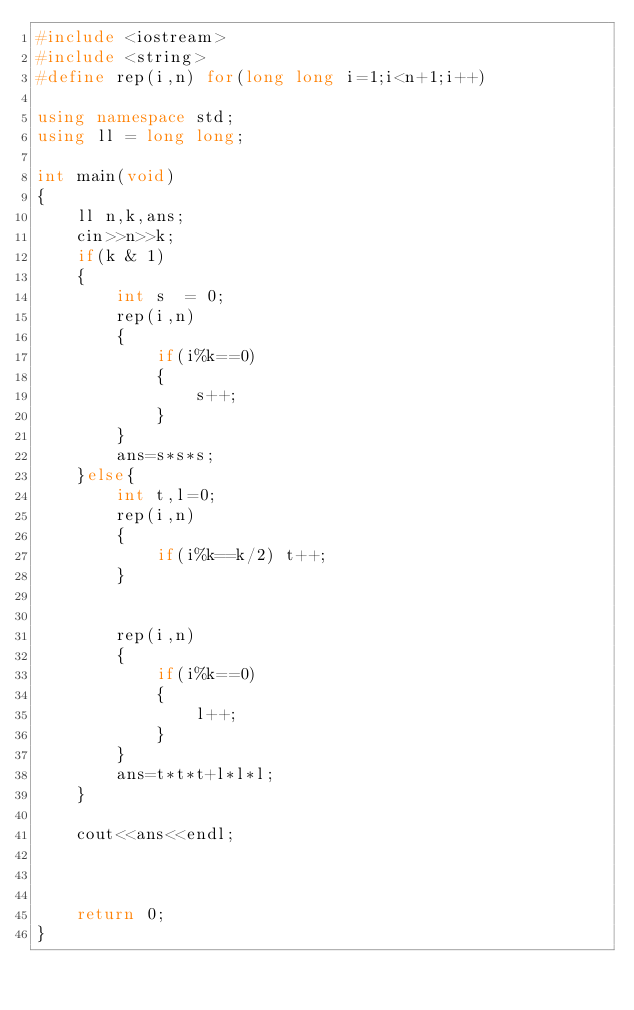Convert code to text. <code><loc_0><loc_0><loc_500><loc_500><_C++_>#include <iostream>
#include <string>
#define rep(i,n) for(long long i=1;i<n+1;i++)

using namespace std;
using ll = long long;

int main(void)
{
    ll n,k,ans;
    cin>>n>>k;
    if(k & 1)
    {
        int s  = 0;
        rep(i,n)
        {
            if(i%k==0)
            {
                s++;
            }
        }
        ans=s*s*s;
    }else{
        int t,l=0;
        rep(i,n)
        {
            if(i%k==k/2) t++;
        }
        
    
        rep(i,n)
        {
            if(i%k==0)
            {
                l++;
            }
        }
        ans=t*t*t+l*l*l;
    }

    cout<<ans<<endl;


    
    return 0;
}
</code> 